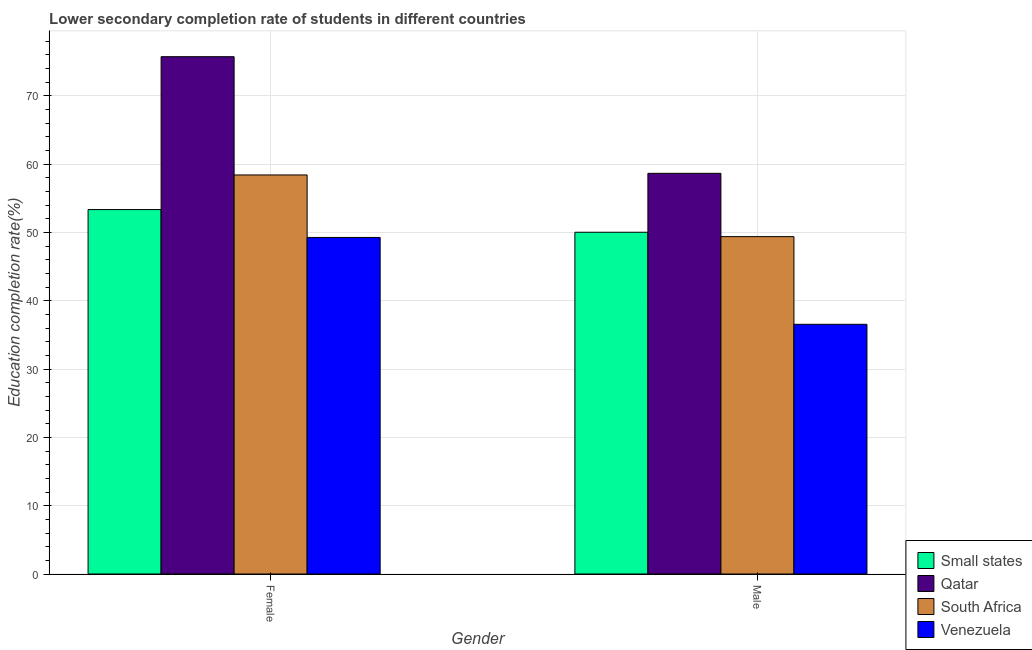How many different coloured bars are there?
Ensure brevity in your answer.  4. How many groups of bars are there?
Provide a succinct answer. 2. Are the number of bars on each tick of the X-axis equal?
Provide a short and direct response. Yes. How many bars are there on the 1st tick from the right?
Ensure brevity in your answer.  4. What is the label of the 2nd group of bars from the left?
Make the answer very short. Male. What is the education completion rate of male students in South Africa?
Your answer should be compact. 49.4. Across all countries, what is the maximum education completion rate of male students?
Your answer should be compact. 58.67. Across all countries, what is the minimum education completion rate of male students?
Keep it short and to the point. 36.56. In which country was the education completion rate of female students maximum?
Your answer should be compact. Qatar. In which country was the education completion rate of male students minimum?
Make the answer very short. Venezuela. What is the total education completion rate of male students in the graph?
Offer a very short reply. 194.68. What is the difference between the education completion rate of male students in South Africa and that in Venezuela?
Make the answer very short. 12.84. What is the difference between the education completion rate of male students in Qatar and the education completion rate of female students in Small states?
Give a very brief answer. 5.31. What is the average education completion rate of male students per country?
Provide a succinct answer. 48.67. What is the difference between the education completion rate of female students and education completion rate of male students in Venezuela?
Provide a succinct answer. 12.72. In how many countries, is the education completion rate of female students greater than 38 %?
Keep it short and to the point. 4. What is the ratio of the education completion rate of female students in Qatar to that in Venezuela?
Keep it short and to the point. 1.54. What does the 4th bar from the left in Male represents?
Keep it short and to the point. Venezuela. What does the 1st bar from the right in Female represents?
Your response must be concise. Venezuela. How many bars are there?
Your answer should be compact. 8. Where does the legend appear in the graph?
Your answer should be very brief. Bottom right. How are the legend labels stacked?
Your response must be concise. Vertical. What is the title of the graph?
Your answer should be compact. Lower secondary completion rate of students in different countries. What is the label or title of the Y-axis?
Provide a succinct answer. Education completion rate(%). What is the Education completion rate(%) in Small states in Female?
Offer a very short reply. 53.36. What is the Education completion rate(%) in Qatar in Female?
Make the answer very short. 75.75. What is the Education completion rate(%) of South Africa in Female?
Give a very brief answer. 58.43. What is the Education completion rate(%) in Venezuela in Female?
Provide a short and direct response. 49.28. What is the Education completion rate(%) in Small states in Male?
Provide a succinct answer. 50.04. What is the Education completion rate(%) in Qatar in Male?
Give a very brief answer. 58.67. What is the Education completion rate(%) of South Africa in Male?
Offer a very short reply. 49.4. What is the Education completion rate(%) of Venezuela in Male?
Your answer should be very brief. 36.56. Across all Gender, what is the maximum Education completion rate(%) in Small states?
Your answer should be compact. 53.36. Across all Gender, what is the maximum Education completion rate(%) of Qatar?
Keep it short and to the point. 75.75. Across all Gender, what is the maximum Education completion rate(%) in South Africa?
Provide a short and direct response. 58.43. Across all Gender, what is the maximum Education completion rate(%) in Venezuela?
Offer a terse response. 49.28. Across all Gender, what is the minimum Education completion rate(%) in Small states?
Provide a succinct answer. 50.04. Across all Gender, what is the minimum Education completion rate(%) in Qatar?
Provide a succinct answer. 58.67. Across all Gender, what is the minimum Education completion rate(%) in South Africa?
Ensure brevity in your answer.  49.4. Across all Gender, what is the minimum Education completion rate(%) in Venezuela?
Offer a terse response. 36.56. What is the total Education completion rate(%) in Small states in the graph?
Your response must be concise. 103.41. What is the total Education completion rate(%) in Qatar in the graph?
Your response must be concise. 134.42. What is the total Education completion rate(%) of South Africa in the graph?
Your answer should be very brief. 107.83. What is the total Education completion rate(%) of Venezuela in the graph?
Make the answer very short. 85.84. What is the difference between the Education completion rate(%) of Small states in Female and that in Male?
Ensure brevity in your answer.  3.32. What is the difference between the Education completion rate(%) of Qatar in Female and that in Male?
Your answer should be very brief. 17.08. What is the difference between the Education completion rate(%) of South Africa in Female and that in Male?
Make the answer very short. 9.03. What is the difference between the Education completion rate(%) of Venezuela in Female and that in Male?
Make the answer very short. 12.72. What is the difference between the Education completion rate(%) of Small states in Female and the Education completion rate(%) of Qatar in Male?
Your answer should be very brief. -5.31. What is the difference between the Education completion rate(%) of Small states in Female and the Education completion rate(%) of South Africa in Male?
Provide a succinct answer. 3.96. What is the difference between the Education completion rate(%) of Small states in Female and the Education completion rate(%) of Venezuela in Male?
Provide a succinct answer. 16.8. What is the difference between the Education completion rate(%) of Qatar in Female and the Education completion rate(%) of South Africa in Male?
Offer a very short reply. 26.35. What is the difference between the Education completion rate(%) of Qatar in Female and the Education completion rate(%) of Venezuela in Male?
Offer a terse response. 39.19. What is the difference between the Education completion rate(%) of South Africa in Female and the Education completion rate(%) of Venezuela in Male?
Provide a short and direct response. 21.87. What is the average Education completion rate(%) of Small states per Gender?
Offer a terse response. 51.7. What is the average Education completion rate(%) in Qatar per Gender?
Offer a terse response. 67.21. What is the average Education completion rate(%) in South Africa per Gender?
Your response must be concise. 53.92. What is the average Education completion rate(%) of Venezuela per Gender?
Provide a succinct answer. 42.92. What is the difference between the Education completion rate(%) of Small states and Education completion rate(%) of Qatar in Female?
Give a very brief answer. -22.39. What is the difference between the Education completion rate(%) of Small states and Education completion rate(%) of South Africa in Female?
Provide a short and direct response. -5.07. What is the difference between the Education completion rate(%) in Small states and Education completion rate(%) in Venezuela in Female?
Provide a succinct answer. 4.08. What is the difference between the Education completion rate(%) in Qatar and Education completion rate(%) in South Africa in Female?
Give a very brief answer. 17.32. What is the difference between the Education completion rate(%) of Qatar and Education completion rate(%) of Venezuela in Female?
Keep it short and to the point. 26.47. What is the difference between the Education completion rate(%) in South Africa and Education completion rate(%) in Venezuela in Female?
Keep it short and to the point. 9.15. What is the difference between the Education completion rate(%) of Small states and Education completion rate(%) of Qatar in Male?
Offer a terse response. -8.63. What is the difference between the Education completion rate(%) in Small states and Education completion rate(%) in South Africa in Male?
Your response must be concise. 0.64. What is the difference between the Education completion rate(%) of Small states and Education completion rate(%) of Venezuela in Male?
Offer a very short reply. 13.48. What is the difference between the Education completion rate(%) in Qatar and Education completion rate(%) in South Africa in Male?
Give a very brief answer. 9.27. What is the difference between the Education completion rate(%) of Qatar and Education completion rate(%) of Venezuela in Male?
Offer a terse response. 22.11. What is the difference between the Education completion rate(%) of South Africa and Education completion rate(%) of Venezuela in Male?
Offer a terse response. 12.84. What is the ratio of the Education completion rate(%) in Small states in Female to that in Male?
Your response must be concise. 1.07. What is the ratio of the Education completion rate(%) of Qatar in Female to that in Male?
Keep it short and to the point. 1.29. What is the ratio of the Education completion rate(%) in South Africa in Female to that in Male?
Your answer should be very brief. 1.18. What is the ratio of the Education completion rate(%) in Venezuela in Female to that in Male?
Your response must be concise. 1.35. What is the difference between the highest and the second highest Education completion rate(%) in Small states?
Ensure brevity in your answer.  3.32. What is the difference between the highest and the second highest Education completion rate(%) in Qatar?
Offer a very short reply. 17.08. What is the difference between the highest and the second highest Education completion rate(%) of South Africa?
Your response must be concise. 9.03. What is the difference between the highest and the second highest Education completion rate(%) in Venezuela?
Offer a very short reply. 12.72. What is the difference between the highest and the lowest Education completion rate(%) in Small states?
Provide a succinct answer. 3.32. What is the difference between the highest and the lowest Education completion rate(%) of Qatar?
Your answer should be very brief. 17.08. What is the difference between the highest and the lowest Education completion rate(%) of South Africa?
Provide a short and direct response. 9.03. What is the difference between the highest and the lowest Education completion rate(%) in Venezuela?
Your answer should be very brief. 12.72. 